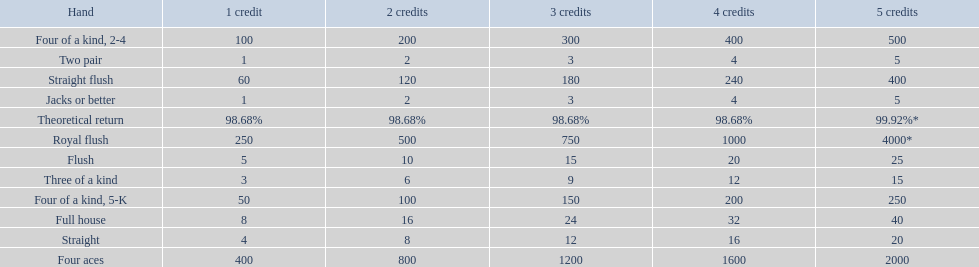What is the values in the 5 credits area? 4000*, 400, 2000, 500, 250, 40, 25, 20, 15, 5, 5. Which of these is for a four of a kind? 500, 250. What is the higher value? 500. What hand is this for Four of a kind, 2-4. 